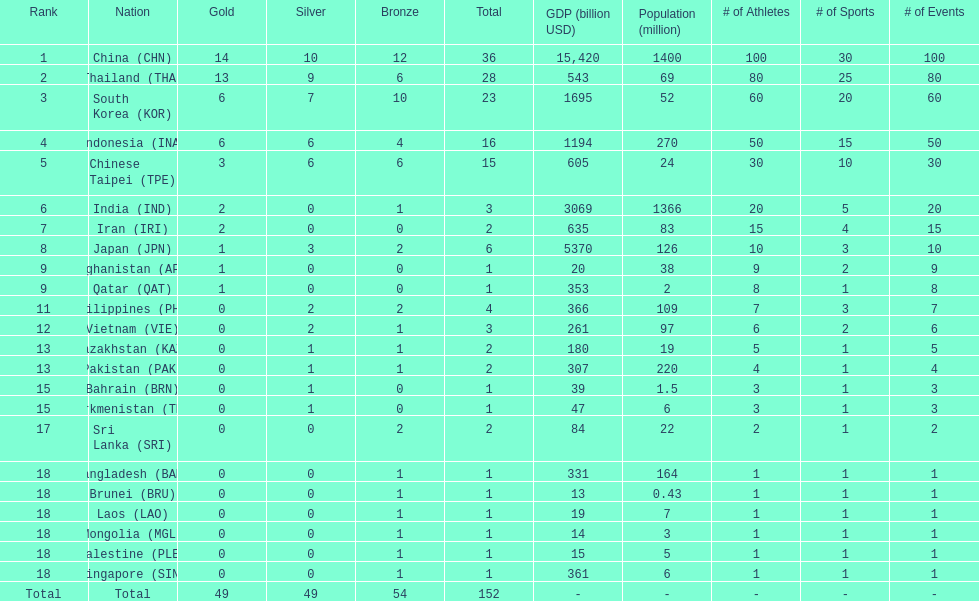How many combined silver medals did china, india, and japan earn ? 13. 